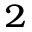<formula> <loc_0><loc_0><loc_500><loc_500>{ ^ { 2 } }</formula> 